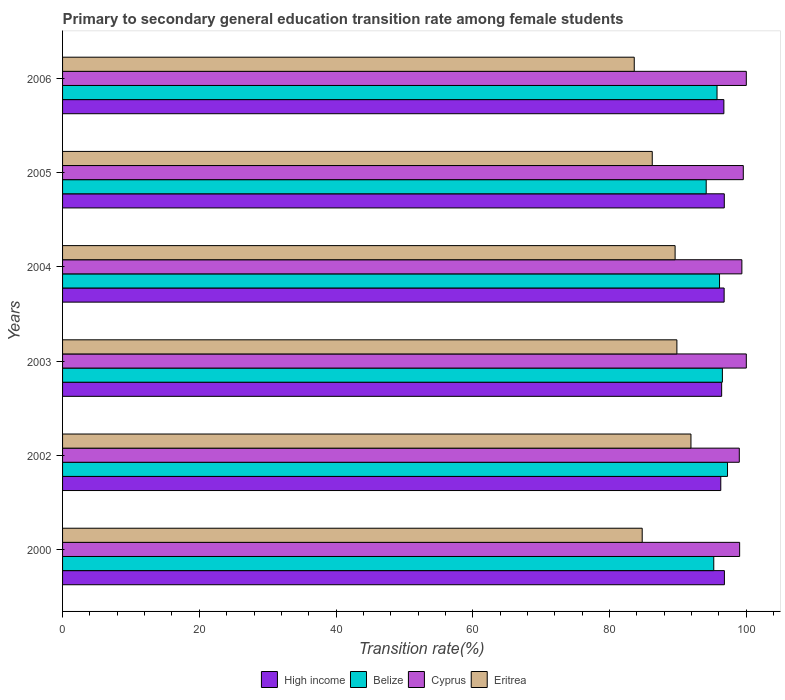Are the number of bars per tick equal to the number of legend labels?
Offer a very short reply. Yes. Are the number of bars on each tick of the Y-axis equal?
Your answer should be very brief. Yes. How many bars are there on the 3rd tick from the bottom?
Give a very brief answer. 4. What is the transition rate in High income in 2004?
Provide a succinct answer. 96.76. Across all years, what is the maximum transition rate in Belize?
Offer a very short reply. 97.25. Across all years, what is the minimum transition rate in Belize?
Ensure brevity in your answer.  94.13. What is the total transition rate in High income in the graph?
Give a very brief answer. 579.72. What is the difference between the transition rate in Belize in 2000 and that in 2006?
Give a very brief answer. -0.48. What is the difference between the transition rate in Cyprus in 2006 and the transition rate in Eritrea in 2000?
Offer a terse response. 15.22. What is the average transition rate in Eritrea per year?
Your response must be concise. 87.66. In the year 2005, what is the difference between the transition rate in Cyprus and transition rate in High income?
Your answer should be very brief. 2.78. In how many years, is the transition rate in Belize greater than 32 %?
Provide a succinct answer. 6. What is the ratio of the transition rate in Eritrea in 2002 to that in 2003?
Give a very brief answer. 1.02. Is the difference between the transition rate in Cyprus in 2003 and 2006 greater than the difference between the transition rate in High income in 2003 and 2006?
Keep it short and to the point. Yes. What is the difference between the highest and the lowest transition rate in Eritrea?
Offer a terse response. 8.29. Is it the case that in every year, the sum of the transition rate in Belize and transition rate in High income is greater than the sum of transition rate in Eritrea and transition rate in Cyprus?
Provide a succinct answer. No. What does the 4th bar from the top in 2000 represents?
Give a very brief answer. High income. What does the 3rd bar from the bottom in 2004 represents?
Keep it short and to the point. Cyprus. Is it the case that in every year, the sum of the transition rate in Belize and transition rate in Eritrea is greater than the transition rate in Cyprus?
Offer a terse response. Yes. Are all the bars in the graph horizontal?
Ensure brevity in your answer.  Yes. Does the graph contain grids?
Offer a very short reply. No. How many legend labels are there?
Offer a very short reply. 4. What is the title of the graph?
Give a very brief answer. Primary to secondary general education transition rate among female students. Does "Brunei Darussalam" appear as one of the legend labels in the graph?
Your answer should be very brief. No. What is the label or title of the X-axis?
Provide a succinct answer. Transition rate(%). What is the Transition rate(%) of High income in 2000?
Offer a very short reply. 96.8. What is the Transition rate(%) in Belize in 2000?
Your response must be concise. 95.24. What is the Transition rate(%) in Cyprus in 2000?
Your answer should be compact. 99.02. What is the Transition rate(%) in Eritrea in 2000?
Provide a short and direct response. 84.78. What is the Transition rate(%) in High income in 2002?
Ensure brevity in your answer.  96.27. What is the Transition rate(%) in Belize in 2002?
Make the answer very short. 97.25. What is the Transition rate(%) in Cyprus in 2002?
Your answer should be compact. 98.97. What is the Transition rate(%) in Eritrea in 2002?
Ensure brevity in your answer.  91.91. What is the Transition rate(%) of High income in 2003?
Your answer should be very brief. 96.4. What is the Transition rate(%) of Belize in 2003?
Your answer should be compact. 96.5. What is the Transition rate(%) of Eritrea in 2003?
Make the answer very short. 89.85. What is the Transition rate(%) in High income in 2004?
Offer a very short reply. 96.76. What is the Transition rate(%) in Belize in 2004?
Your response must be concise. 96.08. What is the Transition rate(%) in Cyprus in 2004?
Ensure brevity in your answer.  99.35. What is the Transition rate(%) in Eritrea in 2004?
Keep it short and to the point. 89.59. What is the Transition rate(%) in High income in 2005?
Give a very brief answer. 96.78. What is the Transition rate(%) of Belize in 2005?
Make the answer very short. 94.13. What is the Transition rate(%) of Cyprus in 2005?
Make the answer very short. 99.56. What is the Transition rate(%) of Eritrea in 2005?
Offer a very short reply. 86.24. What is the Transition rate(%) in High income in 2006?
Make the answer very short. 96.72. What is the Transition rate(%) in Belize in 2006?
Provide a short and direct response. 95.72. What is the Transition rate(%) in Eritrea in 2006?
Make the answer very short. 83.61. Across all years, what is the maximum Transition rate(%) in High income?
Give a very brief answer. 96.8. Across all years, what is the maximum Transition rate(%) in Belize?
Offer a terse response. 97.25. Across all years, what is the maximum Transition rate(%) of Eritrea?
Offer a very short reply. 91.91. Across all years, what is the minimum Transition rate(%) of High income?
Make the answer very short. 96.27. Across all years, what is the minimum Transition rate(%) in Belize?
Ensure brevity in your answer.  94.13. Across all years, what is the minimum Transition rate(%) in Cyprus?
Your answer should be compact. 98.97. Across all years, what is the minimum Transition rate(%) of Eritrea?
Your response must be concise. 83.61. What is the total Transition rate(%) in High income in the graph?
Ensure brevity in your answer.  579.72. What is the total Transition rate(%) in Belize in the graph?
Offer a very short reply. 574.93. What is the total Transition rate(%) of Cyprus in the graph?
Provide a succinct answer. 596.91. What is the total Transition rate(%) of Eritrea in the graph?
Your answer should be very brief. 525.97. What is the difference between the Transition rate(%) in High income in 2000 and that in 2002?
Make the answer very short. 0.53. What is the difference between the Transition rate(%) of Belize in 2000 and that in 2002?
Give a very brief answer. -2.01. What is the difference between the Transition rate(%) of Cyprus in 2000 and that in 2002?
Keep it short and to the point. 0.05. What is the difference between the Transition rate(%) in Eritrea in 2000 and that in 2002?
Give a very brief answer. -7.13. What is the difference between the Transition rate(%) of High income in 2000 and that in 2003?
Give a very brief answer. 0.4. What is the difference between the Transition rate(%) in Belize in 2000 and that in 2003?
Your answer should be very brief. -1.26. What is the difference between the Transition rate(%) in Cyprus in 2000 and that in 2003?
Your response must be concise. -0.98. What is the difference between the Transition rate(%) of Eritrea in 2000 and that in 2003?
Your answer should be very brief. -5.07. What is the difference between the Transition rate(%) of High income in 2000 and that in 2004?
Your answer should be compact. 0.04. What is the difference between the Transition rate(%) in Belize in 2000 and that in 2004?
Keep it short and to the point. -0.84. What is the difference between the Transition rate(%) in Cyprus in 2000 and that in 2004?
Ensure brevity in your answer.  -0.33. What is the difference between the Transition rate(%) in Eritrea in 2000 and that in 2004?
Your response must be concise. -4.81. What is the difference between the Transition rate(%) of High income in 2000 and that in 2005?
Keep it short and to the point. 0.02. What is the difference between the Transition rate(%) in Belize in 2000 and that in 2005?
Ensure brevity in your answer.  1.11. What is the difference between the Transition rate(%) of Cyprus in 2000 and that in 2005?
Your response must be concise. -0.54. What is the difference between the Transition rate(%) in Eritrea in 2000 and that in 2005?
Offer a terse response. -1.47. What is the difference between the Transition rate(%) of High income in 2000 and that in 2006?
Make the answer very short. 0.08. What is the difference between the Transition rate(%) of Belize in 2000 and that in 2006?
Your answer should be very brief. -0.48. What is the difference between the Transition rate(%) of Cyprus in 2000 and that in 2006?
Provide a short and direct response. -0.98. What is the difference between the Transition rate(%) in Eritrea in 2000 and that in 2006?
Make the answer very short. 1.16. What is the difference between the Transition rate(%) in High income in 2002 and that in 2003?
Give a very brief answer. -0.13. What is the difference between the Transition rate(%) of Belize in 2002 and that in 2003?
Your answer should be very brief. 0.75. What is the difference between the Transition rate(%) in Cyprus in 2002 and that in 2003?
Your answer should be compact. -1.03. What is the difference between the Transition rate(%) of Eritrea in 2002 and that in 2003?
Give a very brief answer. 2.06. What is the difference between the Transition rate(%) in High income in 2002 and that in 2004?
Your response must be concise. -0.49. What is the difference between the Transition rate(%) in Belize in 2002 and that in 2004?
Provide a short and direct response. 1.17. What is the difference between the Transition rate(%) in Cyprus in 2002 and that in 2004?
Provide a succinct answer. -0.38. What is the difference between the Transition rate(%) of Eritrea in 2002 and that in 2004?
Your answer should be very brief. 2.32. What is the difference between the Transition rate(%) in High income in 2002 and that in 2005?
Provide a succinct answer. -0.52. What is the difference between the Transition rate(%) of Belize in 2002 and that in 2005?
Ensure brevity in your answer.  3.12. What is the difference between the Transition rate(%) in Cyprus in 2002 and that in 2005?
Ensure brevity in your answer.  -0.59. What is the difference between the Transition rate(%) in Eritrea in 2002 and that in 2005?
Give a very brief answer. 5.66. What is the difference between the Transition rate(%) of High income in 2002 and that in 2006?
Give a very brief answer. -0.45. What is the difference between the Transition rate(%) in Belize in 2002 and that in 2006?
Provide a succinct answer. 1.53. What is the difference between the Transition rate(%) of Cyprus in 2002 and that in 2006?
Provide a short and direct response. -1.03. What is the difference between the Transition rate(%) in Eritrea in 2002 and that in 2006?
Your response must be concise. 8.29. What is the difference between the Transition rate(%) in High income in 2003 and that in 2004?
Make the answer very short. -0.36. What is the difference between the Transition rate(%) in Belize in 2003 and that in 2004?
Your answer should be compact. 0.42. What is the difference between the Transition rate(%) of Cyprus in 2003 and that in 2004?
Provide a succinct answer. 0.65. What is the difference between the Transition rate(%) of Eritrea in 2003 and that in 2004?
Your response must be concise. 0.26. What is the difference between the Transition rate(%) of High income in 2003 and that in 2005?
Provide a succinct answer. -0.39. What is the difference between the Transition rate(%) in Belize in 2003 and that in 2005?
Provide a short and direct response. 2.37. What is the difference between the Transition rate(%) in Cyprus in 2003 and that in 2005?
Provide a succinct answer. 0.44. What is the difference between the Transition rate(%) in Eritrea in 2003 and that in 2005?
Your response must be concise. 3.6. What is the difference between the Transition rate(%) in High income in 2003 and that in 2006?
Your answer should be very brief. -0.32. What is the difference between the Transition rate(%) of Belize in 2003 and that in 2006?
Keep it short and to the point. 0.78. What is the difference between the Transition rate(%) of Cyprus in 2003 and that in 2006?
Your answer should be very brief. 0. What is the difference between the Transition rate(%) of Eritrea in 2003 and that in 2006?
Give a very brief answer. 6.24. What is the difference between the Transition rate(%) of High income in 2004 and that in 2005?
Your answer should be very brief. -0.02. What is the difference between the Transition rate(%) in Belize in 2004 and that in 2005?
Ensure brevity in your answer.  1.95. What is the difference between the Transition rate(%) of Cyprus in 2004 and that in 2005?
Provide a succinct answer. -0.21. What is the difference between the Transition rate(%) in Eritrea in 2004 and that in 2005?
Your response must be concise. 3.34. What is the difference between the Transition rate(%) in High income in 2004 and that in 2006?
Provide a succinct answer. 0.04. What is the difference between the Transition rate(%) of Belize in 2004 and that in 2006?
Keep it short and to the point. 0.37. What is the difference between the Transition rate(%) in Cyprus in 2004 and that in 2006?
Give a very brief answer. -0.65. What is the difference between the Transition rate(%) of Eritrea in 2004 and that in 2006?
Your response must be concise. 5.98. What is the difference between the Transition rate(%) of High income in 2005 and that in 2006?
Your answer should be very brief. 0.06. What is the difference between the Transition rate(%) in Belize in 2005 and that in 2006?
Make the answer very short. -1.58. What is the difference between the Transition rate(%) of Cyprus in 2005 and that in 2006?
Make the answer very short. -0.44. What is the difference between the Transition rate(%) of Eritrea in 2005 and that in 2006?
Offer a terse response. 2.63. What is the difference between the Transition rate(%) in High income in 2000 and the Transition rate(%) in Belize in 2002?
Keep it short and to the point. -0.45. What is the difference between the Transition rate(%) of High income in 2000 and the Transition rate(%) of Cyprus in 2002?
Ensure brevity in your answer.  -2.18. What is the difference between the Transition rate(%) in High income in 2000 and the Transition rate(%) in Eritrea in 2002?
Your response must be concise. 4.89. What is the difference between the Transition rate(%) in Belize in 2000 and the Transition rate(%) in Cyprus in 2002?
Your answer should be very brief. -3.73. What is the difference between the Transition rate(%) of Belize in 2000 and the Transition rate(%) of Eritrea in 2002?
Offer a very short reply. 3.34. What is the difference between the Transition rate(%) in Cyprus in 2000 and the Transition rate(%) in Eritrea in 2002?
Make the answer very short. 7.12. What is the difference between the Transition rate(%) in High income in 2000 and the Transition rate(%) in Belize in 2003?
Give a very brief answer. 0.3. What is the difference between the Transition rate(%) of High income in 2000 and the Transition rate(%) of Cyprus in 2003?
Offer a terse response. -3.2. What is the difference between the Transition rate(%) in High income in 2000 and the Transition rate(%) in Eritrea in 2003?
Provide a succinct answer. 6.95. What is the difference between the Transition rate(%) of Belize in 2000 and the Transition rate(%) of Cyprus in 2003?
Offer a very short reply. -4.76. What is the difference between the Transition rate(%) of Belize in 2000 and the Transition rate(%) of Eritrea in 2003?
Offer a very short reply. 5.39. What is the difference between the Transition rate(%) in Cyprus in 2000 and the Transition rate(%) in Eritrea in 2003?
Offer a terse response. 9.18. What is the difference between the Transition rate(%) in High income in 2000 and the Transition rate(%) in Belize in 2004?
Provide a succinct answer. 0.71. What is the difference between the Transition rate(%) of High income in 2000 and the Transition rate(%) of Cyprus in 2004?
Make the answer very short. -2.55. What is the difference between the Transition rate(%) in High income in 2000 and the Transition rate(%) in Eritrea in 2004?
Ensure brevity in your answer.  7.21. What is the difference between the Transition rate(%) in Belize in 2000 and the Transition rate(%) in Cyprus in 2004?
Make the answer very short. -4.11. What is the difference between the Transition rate(%) of Belize in 2000 and the Transition rate(%) of Eritrea in 2004?
Provide a short and direct response. 5.65. What is the difference between the Transition rate(%) of Cyprus in 2000 and the Transition rate(%) of Eritrea in 2004?
Provide a short and direct response. 9.44. What is the difference between the Transition rate(%) in High income in 2000 and the Transition rate(%) in Belize in 2005?
Give a very brief answer. 2.66. What is the difference between the Transition rate(%) of High income in 2000 and the Transition rate(%) of Cyprus in 2005?
Provide a succinct answer. -2.76. What is the difference between the Transition rate(%) in High income in 2000 and the Transition rate(%) in Eritrea in 2005?
Your response must be concise. 10.56. What is the difference between the Transition rate(%) of Belize in 2000 and the Transition rate(%) of Cyprus in 2005?
Your answer should be compact. -4.32. What is the difference between the Transition rate(%) in Belize in 2000 and the Transition rate(%) in Eritrea in 2005?
Your answer should be very brief. 9. What is the difference between the Transition rate(%) in Cyprus in 2000 and the Transition rate(%) in Eritrea in 2005?
Your answer should be very brief. 12.78. What is the difference between the Transition rate(%) of High income in 2000 and the Transition rate(%) of Belize in 2006?
Ensure brevity in your answer.  1.08. What is the difference between the Transition rate(%) of High income in 2000 and the Transition rate(%) of Cyprus in 2006?
Your response must be concise. -3.2. What is the difference between the Transition rate(%) in High income in 2000 and the Transition rate(%) in Eritrea in 2006?
Your answer should be compact. 13.19. What is the difference between the Transition rate(%) in Belize in 2000 and the Transition rate(%) in Cyprus in 2006?
Ensure brevity in your answer.  -4.76. What is the difference between the Transition rate(%) in Belize in 2000 and the Transition rate(%) in Eritrea in 2006?
Ensure brevity in your answer.  11.63. What is the difference between the Transition rate(%) of Cyprus in 2000 and the Transition rate(%) of Eritrea in 2006?
Offer a terse response. 15.41. What is the difference between the Transition rate(%) of High income in 2002 and the Transition rate(%) of Belize in 2003?
Your answer should be compact. -0.24. What is the difference between the Transition rate(%) of High income in 2002 and the Transition rate(%) of Cyprus in 2003?
Make the answer very short. -3.73. What is the difference between the Transition rate(%) in High income in 2002 and the Transition rate(%) in Eritrea in 2003?
Your response must be concise. 6.42. What is the difference between the Transition rate(%) of Belize in 2002 and the Transition rate(%) of Cyprus in 2003?
Give a very brief answer. -2.75. What is the difference between the Transition rate(%) of Belize in 2002 and the Transition rate(%) of Eritrea in 2003?
Ensure brevity in your answer.  7.4. What is the difference between the Transition rate(%) in Cyprus in 2002 and the Transition rate(%) in Eritrea in 2003?
Your answer should be very brief. 9.13. What is the difference between the Transition rate(%) of High income in 2002 and the Transition rate(%) of Belize in 2004?
Provide a succinct answer. 0.18. What is the difference between the Transition rate(%) of High income in 2002 and the Transition rate(%) of Cyprus in 2004?
Keep it short and to the point. -3.09. What is the difference between the Transition rate(%) of High income in 2002 and the Transition rate(%) of Eritrea in 2004?
Ensure brevity in your answer.  6.68. What is the difference between the Transition rate(%) of Belize in 2002 and the Transition rate(%) of Cyprus in 2004?
Make the answer very short. -2.1. What is the difference between the Transition rate(%) of Belize in 2002 and the Transition rate(%) of Eritrea in 2004?
Keep it short and to the point. 7.66. What is the difference between the Transition rate(%) in Cyprus in 2002 and the Transition rate(%) in Eritrea in 2004?
Your response must be concise. 9.39. What is the difference between the Transition rate(%) in High income in 2002 and the Transition rate(%) in Belize in 2005?
Make the answer very short. 2.13. What is the difference between the Transition rate(%) in High income in 2002 and the Transition rate(%) in Cyprus in 2005?
Offer a very short reply. -3.29. What is the difference between the Transition rate(%) of High income in 2002 and the Transition rate(%) of Eritrea in 2005?
Your answer should be very brief. 10.02. What is the difference between the Transition rate(%) of Belize in 2002 and the Transition rate(%) of Cyprus in 2005?
Offer a terse response. -2.31. What is the difference between the Transition rate(%) in Belize in 2002 and the Transition rate(%) in Eritrea in 2005?
Make the answer very short. 11.01. What is the difference between the Transition rate(%) in Cyprus in 2002 and the Transition rate(%) in Eritrea in 2005?
Give a very brief answer. 12.73. What is the difference between the Transition rate(%) in High income in 2002 and the Transition rate(%) in Belize in 2006?
Offer a terse response. 0.55. What is the difference between the Transition rate(%) in High income in 2002 and the Transition rate(%) in Cyprus in 2006?
Offer a terse response. -3.73. What is the difference between the Transition rate(%) of High income in 2002 and the Transition rate(%) of Eritrea in 2006?
Offer a terse response. 12.65. What is the difference between the Transition rate(%) in Belize in 2002 and the Transition rate(%) in Cyprus in 2006?
Give a very brief answer. -2.75. What is the difference between the Transition rate(%) of Belize in 2002 and the Transition rate(%) of Eritrea in 2006?
Make the answer very short. 13.64. What is the difference between the Transition rate(%) of Cyprus in 2002 and the Transition rate(%) of Eritrea in 2006?
Your response must be concise. 15.36. What is the difference between the Transition rate(%) in High income in 2003 and the Transition rate(%) in Belize in 2004?
Provide a succinct answer. 0.31. What is the difference between the Transition rate(%) in High income in 2003 and the Transition rate(%) in Cyprus in 2004?
Give a very brief answer. -2.96. What is the difference between the Transition rate(%) of High income in 2003 and the Transition rate(%) of Eritrea in 2004?
Make the answer very short. 6.81. What is the difference between the Transition rate(%) in Belize in 2003 and the Transition rate(%) in Cyprus in 2004?
Ensure brevity in your answer.  -2.85. What is the difference between the Transition rate(%) of Belize in 2003 and the Transition rate(%) of Eritrea in 2004?
Offer a very short reply. 6.91. What is the difference between the Transition rate(%) of Cyprus in 2003 and the Transition rate(%) of Eritrea in 2004?
Offer a very short reply. 10.41. What is the difference between the Transition rate(%) of High income in 2003 and the Transition rate(%) of Belize in 2005?
Keep it short and to the point. 2.26. What is the difference between the Transition rate(%) in High income in 2003 and the Transition rate(%) in Cyprus in 2005?
Provide a succinct answer. -3.16. What is the difference between the Transition rate(%) in High income in 2003 and the Transition rate(%) in Eritrea in 2005?
Ensure brevity in your answer.  10.15. What is the difference between the Transition rate(%) in Belize in 2003 and the Transition rate(%) in Cyprus in 2005?
Give a very brief answer. -3.06. What is the difference between the Transition rate(%) in Belize in 2003 and the Transition rate(%) in Eritrea in 2005?
Make the answer very short. 10.26. What is the difference between the Transition rate(%) in Cyprus in 2003 and the Transition rate(%) in Eritrea in 2005?
Make the answer very short. 13.76. What is the difference between the Transition rate(%) in High income in 2003 and the Transition rate(%) in Belize in 2006?
Offer a very short reply. 0.68. What is the difference between the Transition rate(%) in High income in 2003 and the Transition rate(%) in Cyprus in 2006?
Give a very brief answer. -3.6. What is the difference between the Transition rate(%) in High income in 2003 and the Transition rate(%) in Eritrea in 2006?
Ensure brevity in your answer.  12.78. What is the difference between the Transition rate(%) in Belize in 2003 and the Transition rate(%) in Cyprus in 2006?
Your answer should be very brief. -3.5. What is the difference between the Transition rate(%) of Belize in 2003 and the Transition rate(%) of Eritrea in 2006?
Make the answer very short. 12.89. What is the difference between the Transition rate(%) in Cyprus in 2003 and the Transition rate(%) in Eritrea in 2006?
Offer a terse response. 16.39. What is the difference between the Transition rate(%) in High income in 2004 and the Transition rate(%) in Belize in 2005?
Offer a very short reply. 2.62. What is the difference between the Transition rate(%) of High income in 2004 and the Transition rate(%) of Cyprus in 2005?
Provide a short and direct response. -2.8. What is the difference between the Transition rate(%) in High income in 2004 and the Transition rate(%) in Eritrea in 2005?
Ensure brevity in your answer.  10.52. What is the difference between the Transition rate(%) in Belize in 2004 and the Transition rate(%) in Cyprus in 2005?
Offer a very short reply. -3.48. What is the difference between the Transition rate(%) in Belize in 2004 and the Transition rate(%) in Eritrea in 2005?
Ensure brevity in your answer.  9.84. What is the difference between the Transition rate(%) of Cyprus in 2004 and the Transition rate(%) of Eritrea in 2005?
Your response must be concise. 13.11. What is the difference between the Transition rate(%) in High income in 2004 and the Transition rate(%) in Belize in 2006?
Keep it short and to the point. 1.04. What is the difference between the Transition rate(%) in High income in 2004 and the Transition rate(%) in Cyprus in 2006?
Give a very brief answer. -3.24. What is the difference between the Transition rate(%) in High income in 2004 and the Transition rate(%) in Eritrea in 2006?
Provide a succinct answer. 13.15. What is the difference between the Transition rate(%) in Belize in 2004 and the Transition rate(%) in Cyprus in 2006?
Offer a terse response. -3.92. What is the difference between the Transition rate(%) of Belize in 2004 and the Transition rate(%) of Eritrea in 2006?
Ensure brevity in your answer.  12.47. What is the difference between the Transition rate(%) of Cyprus in 2004 and the Transition rate(%) of Eritrea in 2006?
Make the answer very short. 15.74. What is the difference between the Transition rate(%) in High income in 2005 and the Transition rate(%) in Belize in 2006?
Ensure brevity in your answer.  1.06. What is the difference between the Transition rate(%) in High income in 2005 and the Transition rate(%) in Cyprus in 2006?
Ensure brevity in your answer.  -3.22. What is the difference between the Transition rate(%) in High income in 2005 and the Transition rate(%) in Eritrea in 2006?
Offer a very short reply. 13.17. What is the difference between the Transition rate(%) of Belize in 2005 and the Transition rate(%) of Cyprus in 2006?
Provide a short and direct response. -5.87. What is the difference between the Transition rate(%) of Belize in 2005 and the Transition rate(%) of Eritrea in 2006?
Keep it short and to the point. 10.52. What is the difference between the Transition rate(%) of Cyprus in 2005 and the Transition rate(%) of Eritrea in 2006?
Your answer should be very brief. 15.95. What is the average Transition rate(%) in High income per year?
Your answer should be compact. 96.62. What is the average Transition rate(%) of Belize per year?
Keep it short and to the point. 95.82. What is the average Transition rate(%) in Cyprus per year?
Offer a terse response. 99.49. What is the average Transition rate(%) of Eritrea per year?
Your response must be concise. 87.66. In the year 2000, what is the difference between the Transition rate(%) of High income and Transition rate(%) of Belize?
Offer a very short reply. 1.56. In the year 2000, what is the difference between the Transition rate(%) of High income and Transition rate(%) of Cyprus?
Offer a very short reply. -2.23. In the year 2000, what is the difference between the Transition rate(%) in High income and Transition rate(%) in Eritrea?
Your response must be concise. 12.02. In the year 2000, what is the difference between the Transition rate(%) of Belize and Transition rate(%) of Cyprus?
Provide a succinct answer. -3.78. In the year 2000, what is the difference between the Transition rate(%) of Belize and Transition rate(%) of Eritrea?
Keep it short and to the point. 10.47. In the year 2000, what is the difference between the Transition rate(%) in Cyprus and Transition rate(%) in Eritrea?
Provide a succinct answer. 14.25. In the year 2002, what is the difference between the Transition rate(%) in High income and Transition rate(%) in Belize?
Your answer should be very brief. -0.99. In the year 2002, what is the difference between the Transition rate(%) of High income and Transition rate(%) of Cyprus?
Your response must be concise. -2.71. In the year 2002, what is the difference between the Transition rate(%) in High income and Transition rate(%) in Eritrea?
Offer a very short reply. 4.36. In the year 2002, what is the difference between the Transition rate(%) of Belize and Transition rate(%) of Cyprus?
Provide a succinct answer. -1.72. In the year 2002, what is the difference between the Transition rate(%) of Belize and Transition rate(%) of Eritrea?
Your answer should be very brief. 5.35. In the year 2002, what is the difference between the Transition rate(%) in Cyprus and Transition rate(%) in Eritrea?
Make the answer very short. 7.07. In the year 2003, what is the difference between the Transition rate(%) of High income and Transition rate(%) of Belize?
Give a very brief answer. -0.11. In the year 2003, what is the difference between the Transition rate(%) of High income and Transition rate(%) of Cyprus?
Provide a short and direct response. -3.6. In the year 2003, what is the difference between the Transition rate(%) in High income and Transition rate(%) in Eritrea?
Make the answer very short. 6.55. In the year 2003, what is the difference between the Transition rate(%) in Belize and Transition rate(%) in Cyprus?
Make the answer very short. -3.5. In the year 2003, what is the difference between the Transition rate(%) in Belize and Transition rate(%) in Eritrea?
Ensure brevity in your answer.  6.65. In the year 2003, what is the difference between the Transition rate(%) in Cyprus and Transition rate(%) in Eritrea?
Give a very brief answer. 10.15. In the year 2004, what is the difference between the Transition rate(%) in High income and Transition rate(%) in Belize?
Provide a short and direct response. 0.68. In the year 2004, what is the difference between the Transition rate(%) in High income and Transition rate(%) in Cyprus?
Provide a succinct answer. -2.59. In the year 2004, what is the difference between the Transition rate(%) of High income and Transition rate(%) of Eritrea?
Make the answer very short. 7.17. In the year 2004, what is the difference between the Transition rate(%) in Belize and Transition rate(%) in Cyprus?
Your response must be concise. -3.27. In the year 2004, what is the difference between the Transition rate(%) in Belize and Transition rate(%) in Eritrea?
Give a very brief answer. 6.5. In the year 2004, what is the difference between the Transition rate(%) of Cyprus and Transition rate(%) of Eritrea?
Make the answer very short. 9.77. In the year 2005, what is the difference between the Transition rate(%) in High income and Transition rate(%) in Belize?
Offer a terse response. 2.65. In the year 2005, what is the difference between the Transition rate(%) in High income and Transition rate(%) in Cyprus?
Your answer should be very brief. -2.78. In the year 2005, what is the difference between the Transition rate(%) of High income and Transition rate(%) of Eritrea?
Your answer should be compact. 10.54. In the year 2005, what is the difference between the Transition rate(%) in Belize and Transition rate(%) in Cyprus?
Your answer should be very brief. -5.43. In the year 2005, what is the difference between the Transition rate(%) of Belize and Transition rate(%) of Eritrea?
Give a very brief answer. 7.89. In the year 2005, what is the difference between the Transition rate(%) of Cyprus and Transition rate(%) of Eritrea?
Ensure brevity in your answer.  13.32. In the year 2006, what is the difference between the Transition rate(%) of High income and Transition rate(%) of Belize?
Your response must be concise. 1. In the year 2006, what is the difference between the Transition rate(%) of High income and Transition rate(%) of Cyprus?
Ensure brevity in your answer.  -3.28. In the year 2006, what is the difference between the Transition rate(%) of High income and Transition rate(%) of Eritrea?
Ensure brevity in your answer.  13.11. In the year 2006, what is the difference between the Transition rate(%) of Belize and Transition rate(%) of Cyprus?
Offer a terse response. -4.28. In the year 2006, what is the difference between the Transition rate(%) in Belize and Transition rate(%) in Eritrea?
Keep it short and to the point. 12.11. In the year 2006, what is the difference between the Transition rate(%) in Cyprus and Transition rate(%) in Eritrea?
Keep it short and to the point. 16.39. What is the ratio of the Transition rate(%) in High income in 2000 to that in 2002?
Your answer should be compact. 1.01. What is the ratio of the Transition rate(%) in Belize in 2000 to that in 2002?
Offer a terse response. 0.98. What is the ratio of the Transition rate(%) of Cyprus in 2000 to that in 2002?
Your response must be concise. 1. What is the ratio of the Transition rate(%) in Eritrea in 2000 to that in 2002?
Provide a short and direct response. 0.92. What is the ratio of the Transition rate(%) of Belize in 2000 to that in 2003?
Your answer should be compact. 0.99. What is the ratio of the Transition rate(%) in Cyprus in 2000 to that in 2003?
Keep it short and to the point. 0.99. What is the ratio of the Transition rate(%) of Eritrea in 2000 to that in 2003?
Your answer should be compact. 0.94. What is the ratio of the Transition rate(%) in Belize in 2000 to that in 2004?
Offer a terse response. 0.99. What is the ratio of the Transition rate(%) in Eritrea in 2000 to that in 2004?
Offer a very short reply. 0.95. What is the ratio of the Transition rate(%) of Belize in 2000 to that in 2005?
Provide a succinct answer. 1.01. What is the ratio of the Transition rate(%) in Belize in 2000 to that in 2006?
Keep it short and to the point. 0.99. What is the ratio of the Transition rate(%) of Cyprus in 2000 to that in 2006?
Give a very brief answer. 0.99. What is the ratio of the Transition rate(%) of Eritrea in 2000 to that in 2006?
Keep it short and to the point. 1.01. What is the ratio of the Transition rate(%) in Eritrea in 2002 to that in 2003?
Offer a terse response. 1.02. What is the ratio of the Transition rate(%) in High income in 2002 to that in 2004?
Provide a succinct answer. 0.99. What is the ratio of the Transition rate(%) of Belize in 2002 to that in 2004?
Provide a succinct answer. 1.01. What is the ratio of the Transition rate(%) of Cyprus in 2002 to that in 2004?
Offer a terse response. 1. What is the ratio of the Transition rate(%) in Eritrea in 2002 to that in 2004?
Provide a succinct answer. 1.03. What is the ratio of the Transition rate(%) of High income in 2002 to that in 2005?
Offer a terse response. 0.99. What is the ratio of the Transition rate(%) in Belize in 2002 to that in 2005?
Offer a very short reply. 1.03. What is the ratio of the Transition rate(%) in Cyprus in 2002 to that in 2005?
Make the answer very short. 0.99. What is the ratio of the Transition rate(%) in Eritrea in 2002 to that in 2005?
Your answer should be very brief. 1.07. What is the ratio of the Transition rate(%) in Eritrea in 2002 to that in 2006?
Provide a succinct answer. 1.1. What is the ratio of the Transition rate(%) of High income in 2003 to that in 2004?
Offer a terse response. 1. What is the ratio of the Transition rate(%) of Belize in 2003 to that in 2004?
Your answer should be compact. 1. What is the ratio of the Transition rate(%) in Belize in 2003 to that in 2005?
Provide a succinct answer. 1.03. What is the ratio of the Transition rate(%) of Eritrea in 2003 to that in 2005?
Your answer should be very brief. 1.04. What is the ratio of the Transition rate(%) in Belize in 2003 to that in 2006?
Give a very brief answer. 1.01. What is the ratio of the Transition rate(%) in Cyprus in 2003 to that in 2006?
Your answer should be compact. 1. What is the ratio of the Transition rate(%) of Eritrea in 2003 to that in 2006?
Give a very brief answer. 1.07. What is the ratio of the Transition rate(%) of High income in 2004 to that in 2005?
Make the answer very short. 1. What is the ratio of the Transition rate(%) in Belize in 2004 to that in 2005?
Your answer should be compact. 1.02. What is the ratio of the Transition rate(%) of Eritrea in 2004 to that in 2005?
Your answer should be compact. 1.04. What is the ratio of the Transition rate(%) in Eritrea in 2004 to that in 2006?
Give a very brief answer. 1.07. What is the ratio of the Transition rate(%) of High income in 2005 to that in 2006?
Provide a short and direct response. 1. What is the ratio of the Transition rate(%) in Belize in 2005 to that in 2006?
Provide a succinct answer. 0.98. What is the ratio of the Transition rate(%) of Eritrea in 2005 to that in 2006?
Offer a very short reply. 1.03. What is the difference between the highest and the second highest Transition rate(%) in High income?
Keep it short and to the point. 0.02. What is the difference between the highest and the second highest Transition rate(%) of Belize?
Make the answer very short. 0.75. What is the difference between the highest and the second highest Transition rate(%) of Eritrea?
Provide a short and direct response. 2.06. What is the difference between the highest and the lowest Transition rate(%) in High income?
Offer a very short reply. 0.53. What is the difference between the highest and the lowest Transition rate(%) in Belize?
Keep it short and to the point. 3.12. What is the difference between the highest and the lowest Transition rate(%) of Cyprus?
Give a very brief answer. 1.03. What is the difference between the highest and the lowest Transition rate(%) of Eritrea?
Provide a short and direct response. 8.29. 